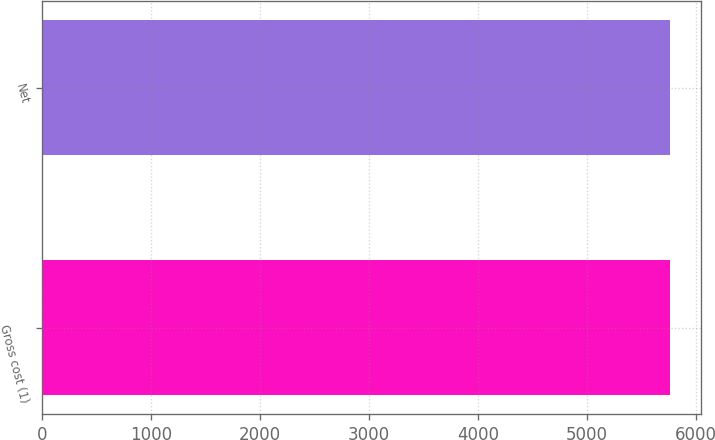Convert chart to OTSL. <chart><loc_0><loc_0><loc_500><loc_500><bar_chart><fcel>Gross cost (1)<fcel>Net<nl><fcel>5758<fcel>5758.1<nl></chart> 